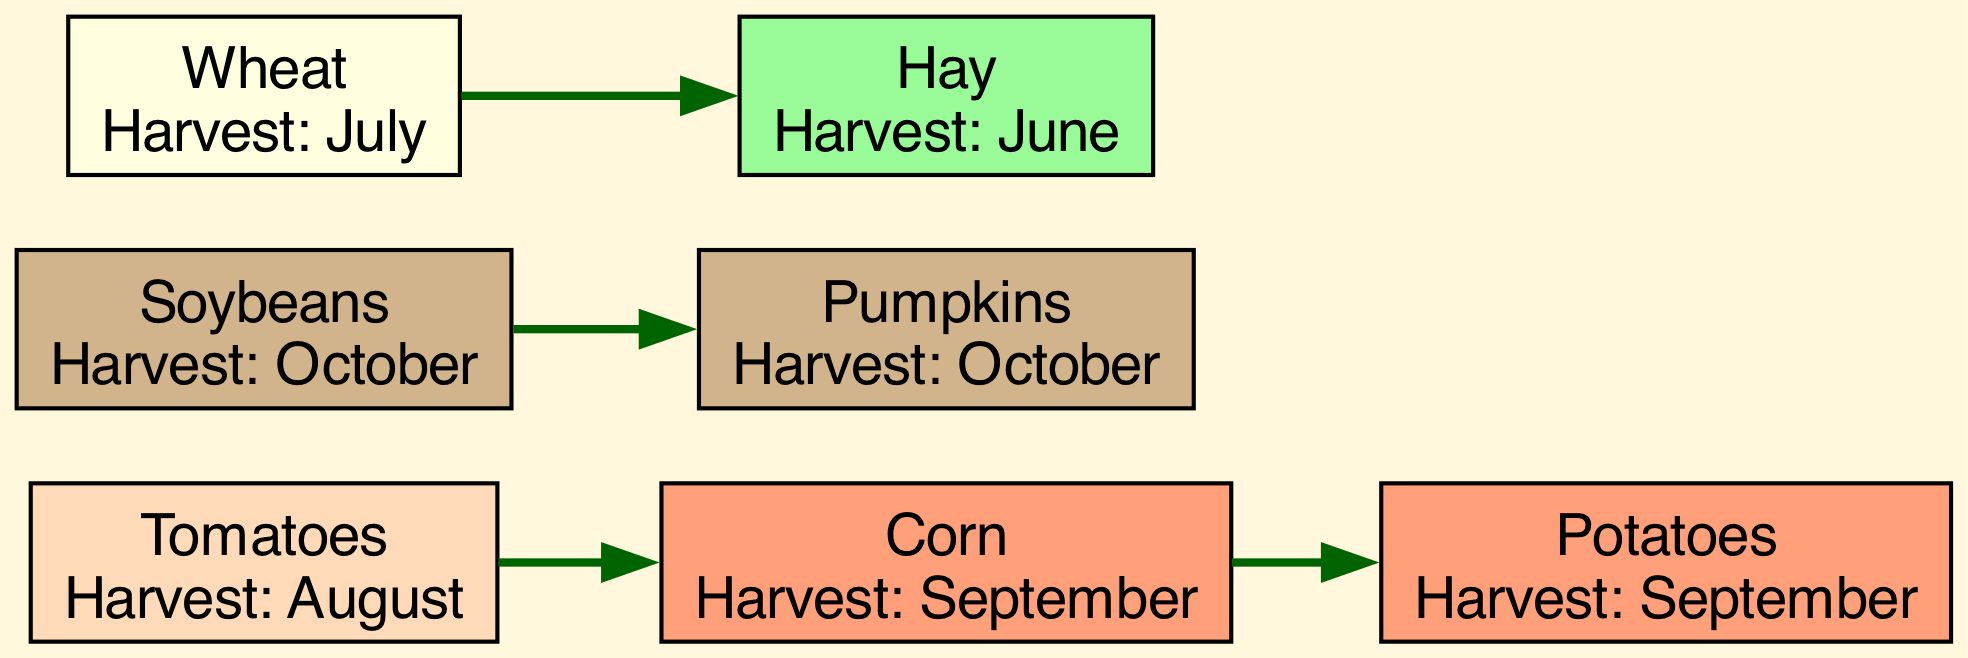What is the harvest time for Corn? The node labeled "Corn" specifies its harvest time as "September," which is clearly indicated in its description.
Answer: September How many crops are harvested in October? Based on the diagram, there are two nodes (Soybeans and Pumpkins) labeled with "October" as their harvest time, which can be counted from the corresponding nodes.
Answer: 2 Which crop is harvested in July? The node representing "Wheat" indicates that its harvest time is "July," as shown in its label.
Answer: Wheat What is the relationship between Tomatoes and Corn? The diagram shows an edge directed from "Tomatoes" to "Corn," indicating that Tomatoes are linked to Corn as a source crop that leads to Corn.
Answer: Tomatoes point to Corn Which crop do Soybeans lead to? The diagram reveals an edge directed from "Soybeans" to "Pumpkins," meaning Soybeans lead to the harvesting of Pumpkins.
Answer: Pumpkins How many edges are represented in the diagram? By examining all the edges connecting the nodes, there are four edges shown that connect the various crops throughout the diagram.
Answer: 4 If a farmer grows Potatoes, what is the preceding crop in the harvest schedule? The diagram contains an edge going from "Corn" to "Potatoes," indicating that Corn comes before Potatoes within the harvesting flow.
Answer: Corn Which crops are harvested before Hay? In the directed graph, "Wheat" is shown to lead to "Hay," meaning Wheat is harvested first before Hay in the schedule.
Answer: Wheat What is the harvest time for Potatoes? The label for the Potatoes node indicates that they are harvested in "September," which can be easily referred to by looking at the node's information.
Answer: September 